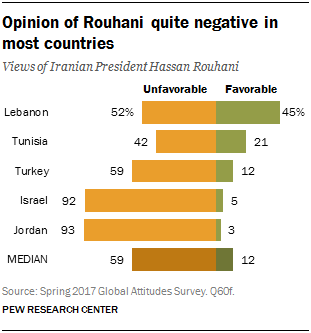Mention a couple of crucial points in this snapshot. Out of all the countries included in the Favorable group, Lebanon had the highest value. It is possible that Turkey has a value that is unfavorable and the median value is the same as the unfavorable value. 